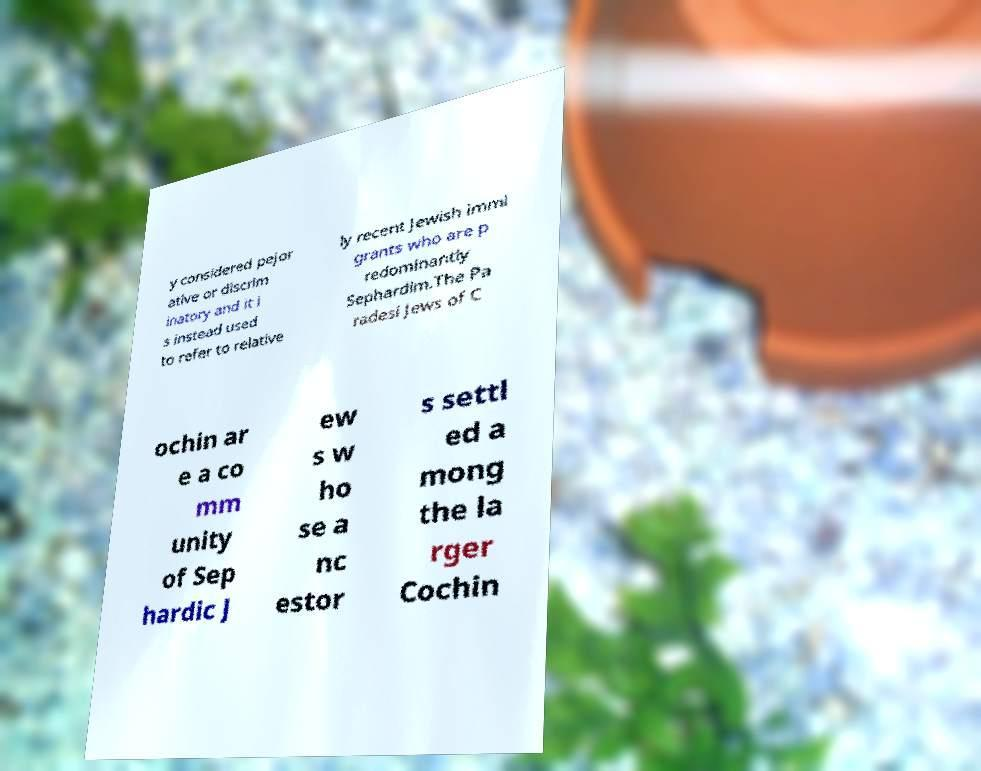Can you read and provide the text displayed in the image?This photo seems to have some interesting text. Can you extract and type it out for me? y considered pejor ative or discrim inatory and it i s instead used to refer to relative ly recent Jewish immi grants who are p redominantly Sephardim.The Pa radesi Jews of C ochin ar e a co mm unity of Sep hardic J ew s w ho se a nc estor s settl ed a mong the la rger Cochin 